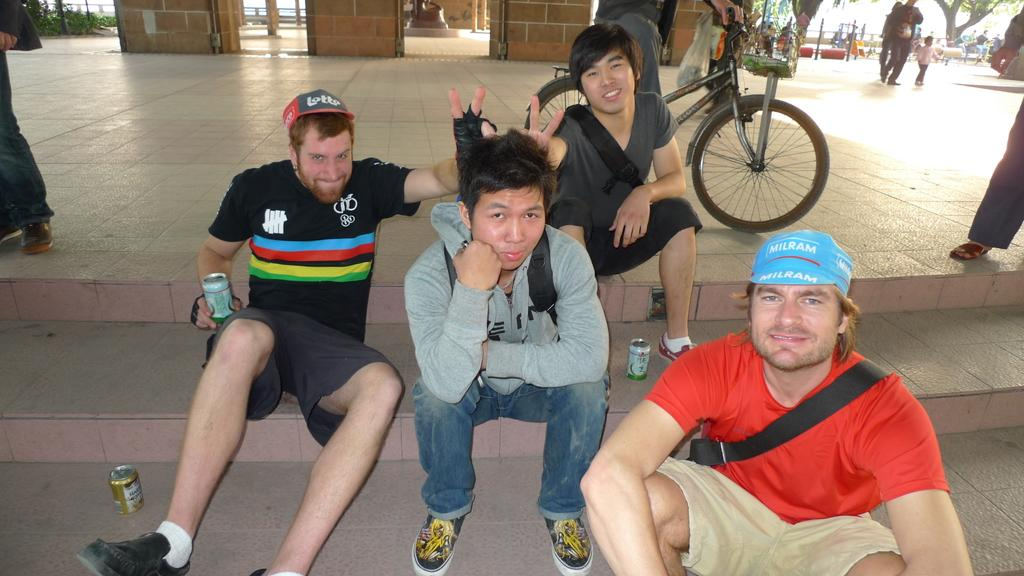What are the people in the image doing? The people in the image are sitting on the floor. Can you describe the position of one of the people in the image? There is a person sitting on a bicycle in the image. What type of bead is being used as a decoration on the school in the image? There is no school or bead present in the image. Can you describe the color of the toad sitting next to the person on the bicycle? There is no toad present in the image. 